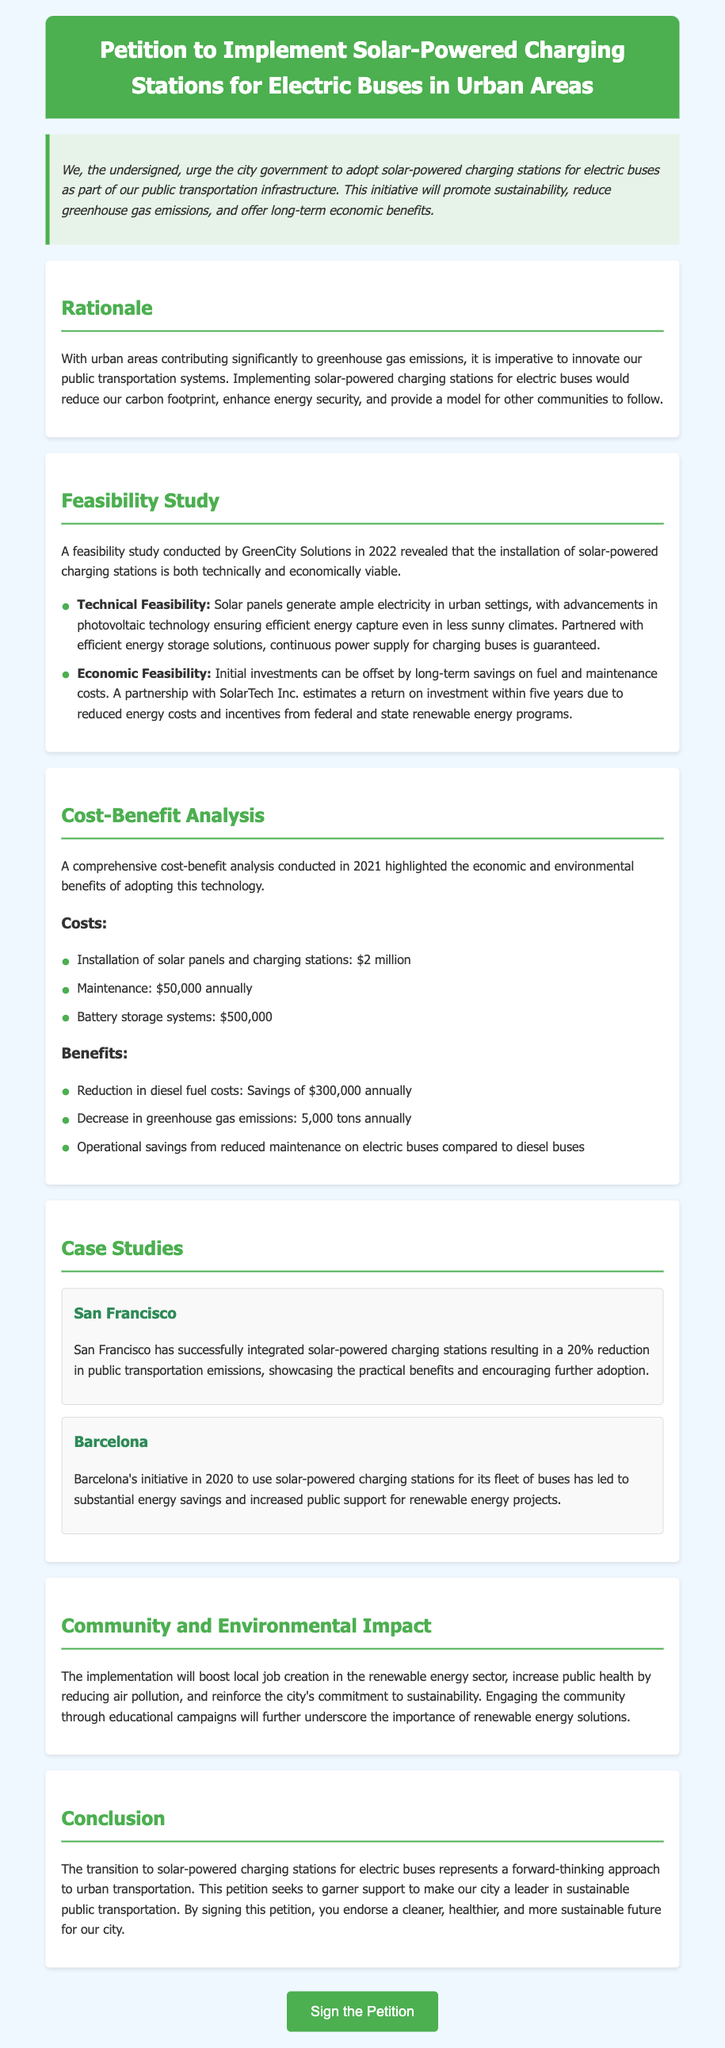What is the primary aim of the petition? The primary aim is to urge the city government to adopt solar-powered charging stations for electric buses as part of public transportation infrastructure.
Answer: Adopt solar-powered charging stations What year was the feasibility study conducted? The feasibility study was conducted by GreenCity Solutions in 2022.
Answer: 2022 What is the estimated installation cost of solar panels and charging stations? The document lists the installation of solar panels and charging stations at $2 million.
Answer: $2 million How much can be saved annually on diesel fuel costs? The savings on diesel fuel costs is stated as $300,000 annually.
Answer: $300,000 Which city implemented solar-powered charging stations and reduced emissions by 20%? San Francisco is mentioned as having successfully integrated solar-powered charging stations resulting in a 20% reduction in emissions.
Answer: San Francisco What is the expected return on investment timeframe according to the partnership with SolarTech Inc.? The expected return on investment is within five years.
Answer: Five years What is one of the economic benefits highlighted in the analysis? One economic benefit mentioned is a decrease in greenhouse gas emissions by 5,000 tons annually.
Answer: Decrease in greenhouse gas emissions by 5,000 tons In which year did Barcelona start using solar-powered charging stations for its bus fleet? Barcelona started using solar-powered charging stations in 2020.
Answer: 2020 What is mentioned as a potential community impact from the implementation? The petition states that the implementation will boost local job creation in the renewable energy sector.
Answer: Job creation in renewable energy sector 